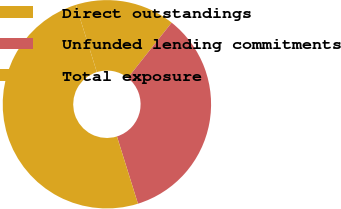Convert chart. <chart><loc_0><loc_0><loc_500><loc_500><pie_chart><fcel>Direct outstandings<fcel>Unfunded lending commitments<fcel>Total exposure<nl><fcel>15.49%<fcel>34.51%<fcel>50.0%<nl></chart> 